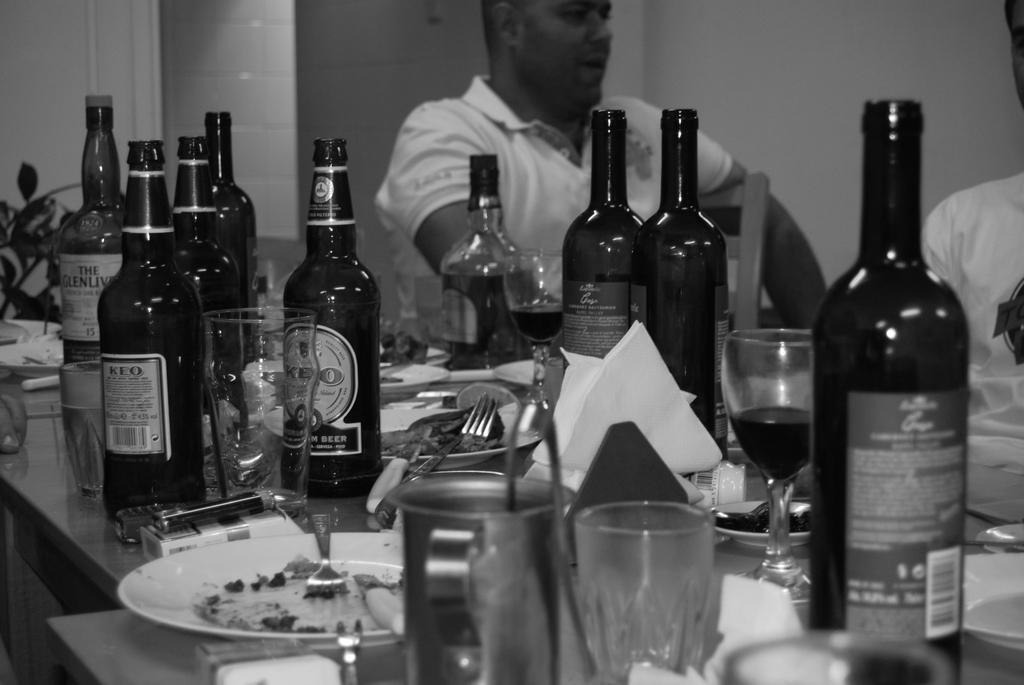What is the man in the image wearing? The man is wearing a white t-shirt. What is in front of the man in the image? There is a table in front of the man. What items can be seen on the table? There are many bottles, glasses, plates, forks, packets, and a mobile on the table. What type of record can be heard playing in the background of the image? There is no record or sound present in the image; it is a still photograph. 